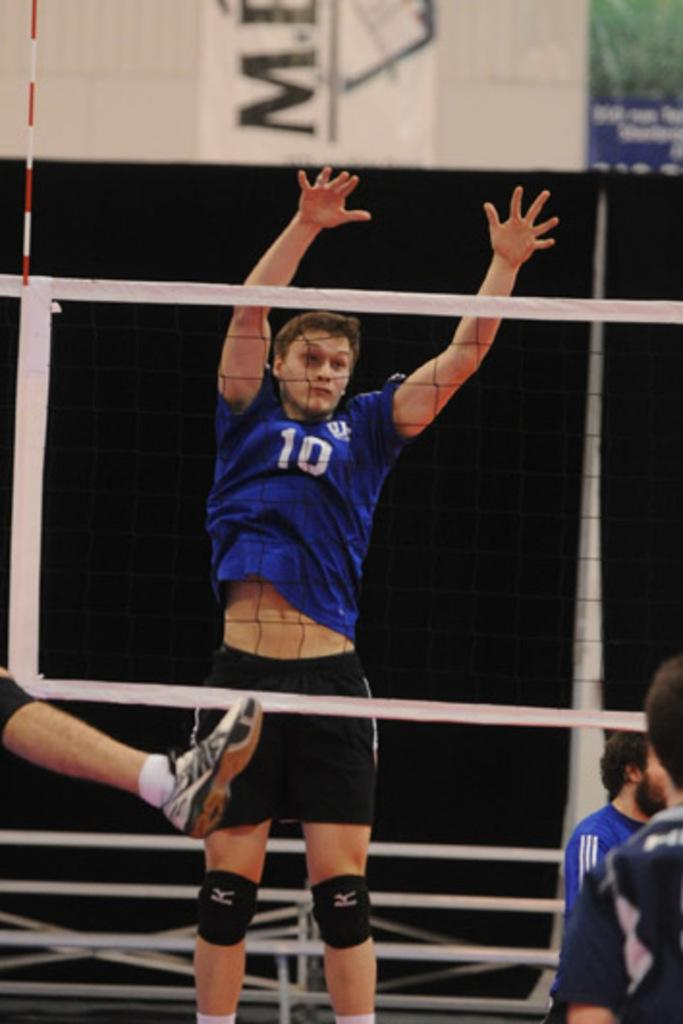<image>
Write a terse but informative summary of the picture. A male volleyball player wearing a number 10 jersey jumps above the volleyball net with his hands up. 